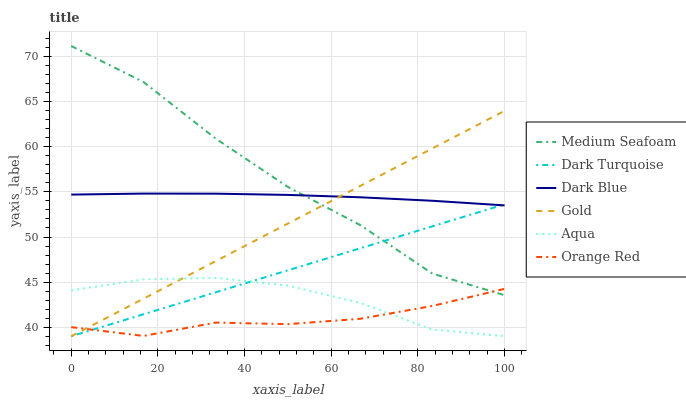Does Orange Red have the minimum area under the curve?
Answer yes or no. Yes. Does Medium Seafoam have the maximum area under the curve?
Answer yes or no. Yes. Does Dark Turquoise have the minimum area under the curve?
Answer yes or no. No. Does Dark Turquoise have the maximum area under the curve?
Answer yes or no. No. Is Dark Turquoise the smoothest?
Answer yes or no. Yes. Is Medium Seafoam the roughest?
Answer yes or no. Yes. Is Aqua the smoothest?
Answer yes or no. No. Is Aqua the roughest?
Answer yes or no. No. Does Gold have the lowest value?
Answer yes or no. Yes. Does Medium Seafoam have the lowest value?
Answer yes or no. No. Does Medium Seafoam have the highest value?
Answer yes or no. Yes. Does Dark Turquoise have the highest value?
Answer yes or no. No. Is Aqua less than Medium Seafoam?
Answer yes or no. Yes. Is Dark Blue greater than Orange Red?
Answer yes or no. Yes. Does Aqua intersect Gold?
Answer yes or no. Yes. Is Aqua less than Gold?
Answer yes or no. No. Is Aqua greater than Gold?
Answer yes or no. No. Does Aqua intersect Medium Seafoam?
Answer yes or no. No. 